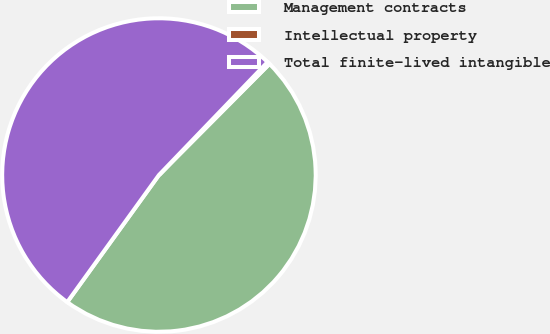Convert chart. <chart><loc_0><loc_0><loc_500><loc_500><pie_chart><fcel>Management contracts<fcel>Intellectual property<fcel>Total finite-lived intangible<nl><fcel>47.49%<fcel>0.27%<fcel>52.24%<nl></chart> 